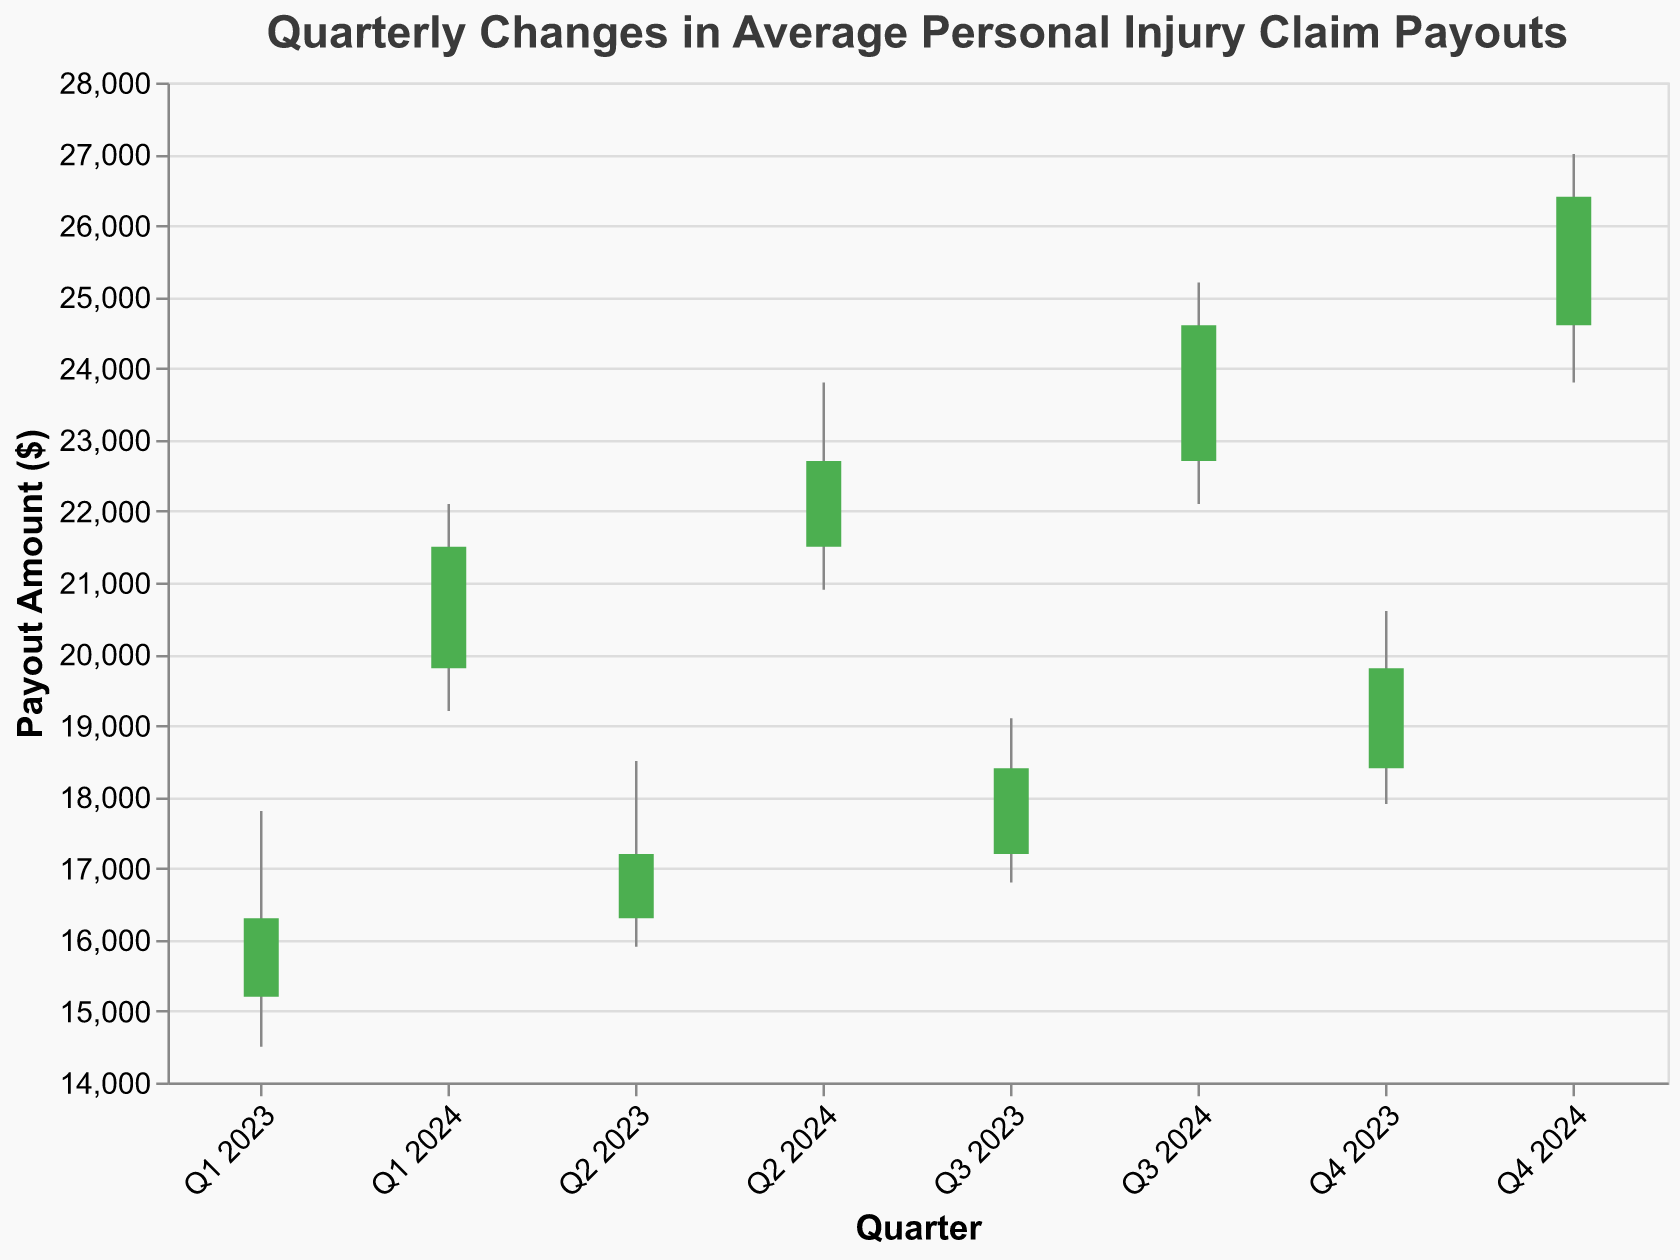What is the highest payout recorded in the entire figure? The highest payout recorded is the maximum value in the "High" field over all the quarters. Here, the highest value is observed in Q4 2024, at $27000.
Answer: $27000 Which quarter shows the lowest average payout? The lowest average payout can be found by looking at the "Low" column, which represents the minimum value over the quarter. The lowest value is in Q1 2023 at $14500.
Answer: $14500 How much did the average payout increase from Q1 2023 to Q4 2024? The increase is found by subtracting the "Open" value of Q1 2023 from the "Close" value of Q4 2024. Thus, $26400 - $15200 = $11200.
Answer: $11200 In which quarter of 2024 did the highest opening payout occur? The opening payout for each quarter of 2024 is: Q1 2024 - $19800, Q2 2024 - $21500, Q3 2024 - $22700, Q4 2024 - $24600. The highest occurs in Q4 2024 at $24600.
Answer: Q4 2024 How does the average closing payout in Q2 2024 compare to Q3 2024? The closing payout for Q2 2024 is $22700 and for Q3 2024 is $24600. Comparing these, $24600 is greater than $22700.
Answer: Q3 2024 is higher What was the overall trend in the payouts from Q1 2023 to Q4 2024? The overall trend can be observed by comparing the opening value in Q1 2023 ($15200) and the closing value in Q4 2024 ($26400). The chart shows a consistent increase over the quarters, indicating an upward trend.
Answer: Upward trend In which quarter did the smallest difference between the highest and lowest payouts occur? The smallest difference between "High" and "Low" can be calculated for each quarter. The differences are: Q1 2023 - $3300, Q2 2023 - $2600, Q3 2023 - $2300, Q4 2023 - $2700, Q1 2024 - $2900, Q2 2024 - $2900, Q3 2024 - $3100, Q4 2024 - $3200. The smallest difference occurs in Q3 2023 with $2300.
Answer: Q3 2023 What is the average closing payout across all quarters shown? The closing payouts for each quarter are: $16300, $17200, $18400, $19800, $21500, $22700, $24600, $26400. Adding these together gives $166900, and dividing by 8 quarters gives an average of $20862.50.
Answer: $20862.50 Which quarter experienced the largest growth in average payout during the quarter? Growth is determined by the difference between "Close" and "Open" for each quarter. The largest difference occurs in Q1 2024 with an increase of $1700 ($21500 - $19800).
Answer: Q1 2024 